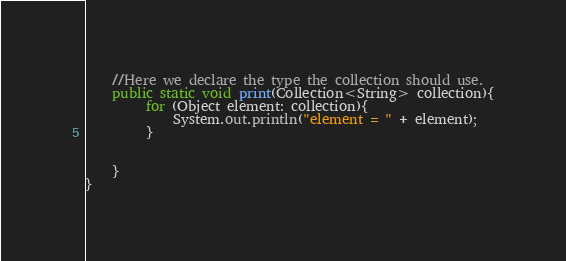Convert code to text. <code><loc_0><loc_0><loc_500><loc_500><_Java_>    //Here we declare the type the collection should use.
    public static void print(Collection<String> collection){
         for (Object element: collection){
             System.out.println("element = " + element);
         }


    }
}
</code> 